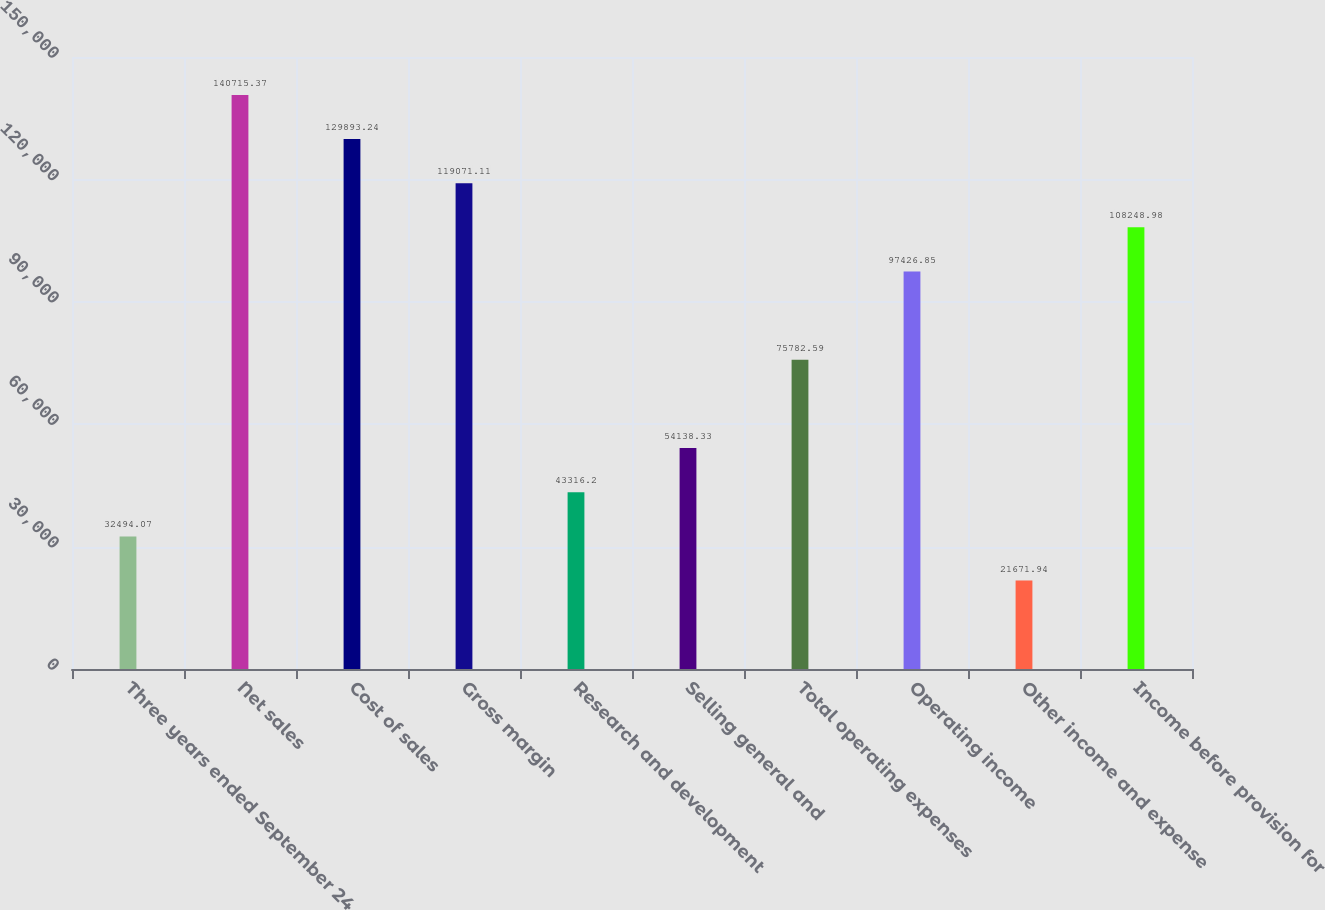Convert chart. <chart><loc_0><loc_0><loc_500><loc_500><bar_chart><fcel>Three years ended September 24<fcel>Net sales<fcel>Cost of sales<fcel>Gross margin<fcel>Research and development<fcel>Selling general and<fcel>Total operating expenses<fcel>Operating income<fcel>Other income and expense<fcel>Income before provision for<nl><fcel>32494.1<fcel>140715<fcel>129893<fcel>119071<fcel>43316.2<fcel>54138.3<fcel>75782.6<fcel>97426.9<fcel>21671.9<fcel>108249<nl></chart> 